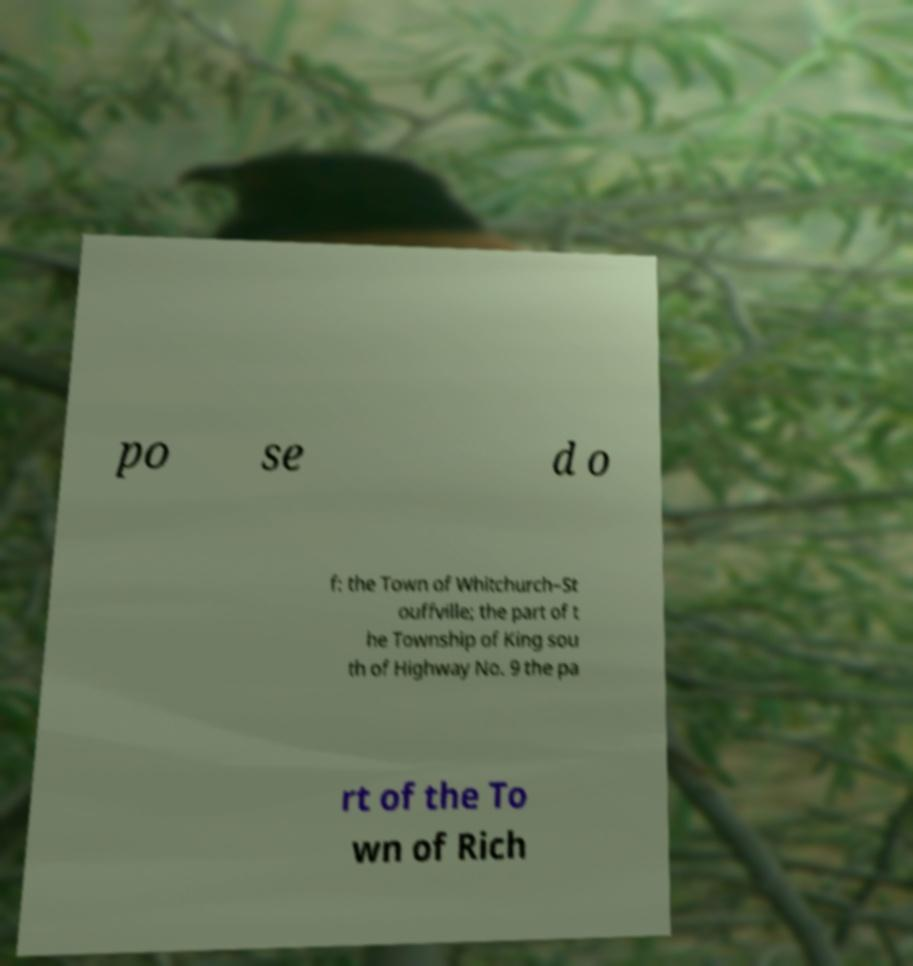I need the written content from this picture converted into text. Can you do that? po se d o f: the Town of Whitchurch–St ouffville; the part of t he Township of King sou th of Highway No. 9 the pa rt of the To wn of Rich 